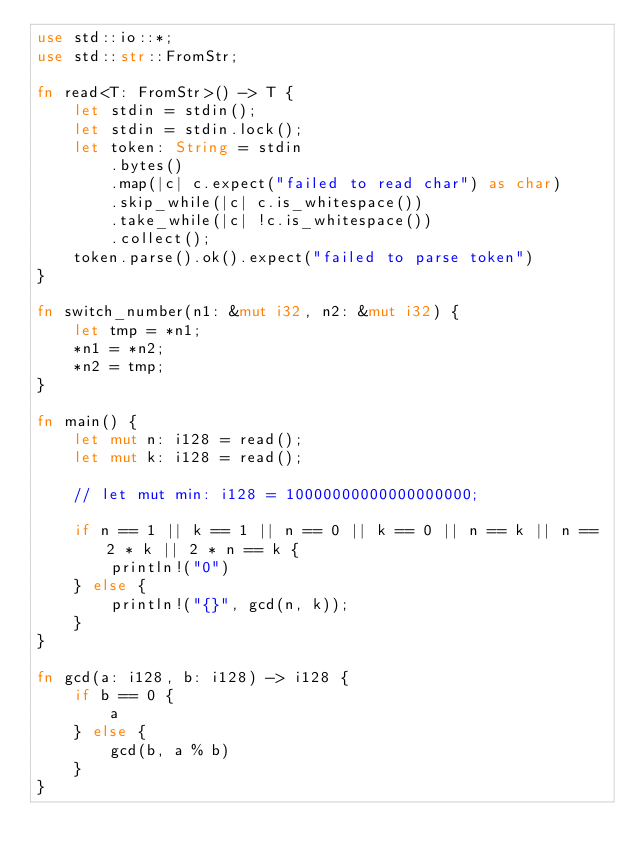Convert code to text. <code><loc_0><loc_0><loc_500><loc_500><_Rust_>use std::io::*;
use std::str::FromStr;

fn read<T: FromStr>() -> T {
    let stdin = stdin();
    let stdin = stdin.lock();
    let token: String = stdin
        .bytes()
        .map(|c| c.expect("failed to read char") as char)
        .skip_while(|c| c.is_whitespace())
        .take_while(|c| !c.is_whitespace())
        .collect();
    token.parse().ok().expect("failed to parse token")
}

fn switch_number(n1: &mut i32, n2: &mut i32) {
    let tmp = *n1;
    *n1 = *n2;
    *n2 = tmp;
}

fn main() {
    let mut n: i128 = read();
    let mut k: i128 = read();

    // let mut min: i128 = 10000000000000000000;

    if n == 1 || k == 1 || n == 0 || k == 0 || n == k || n == 2 * k || 2 * n == k {
        println!("0")
    } else {
        println!("{}", gcd(n, k));
    }
}

fn gcd(a: i128, b: i128) -> i128 {
    if b == 0 {
        a
    } else {
        gcd(b, a % b)
    }
}
</code> 